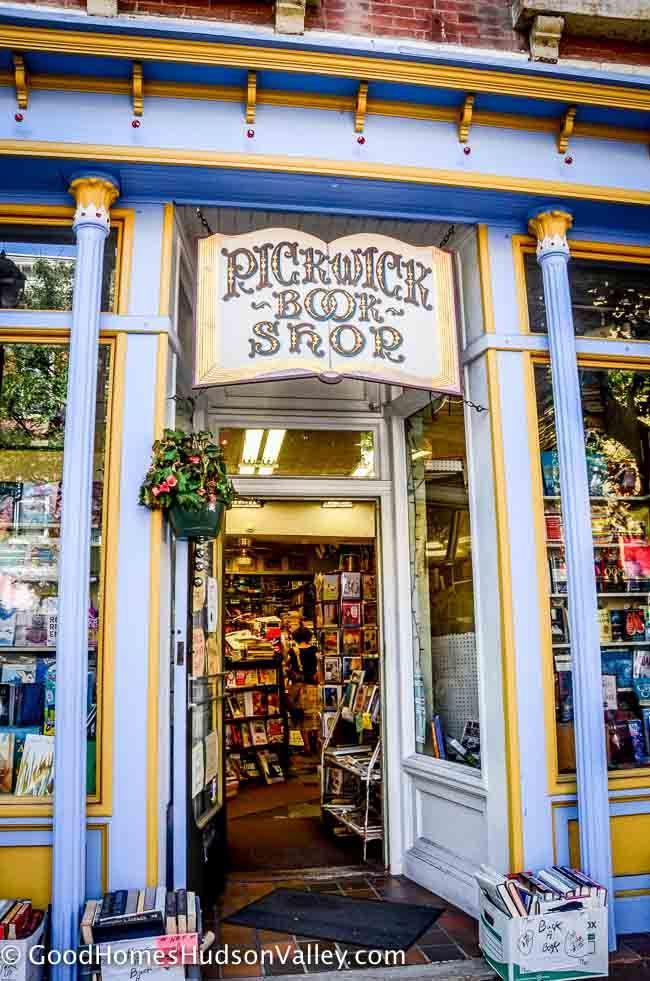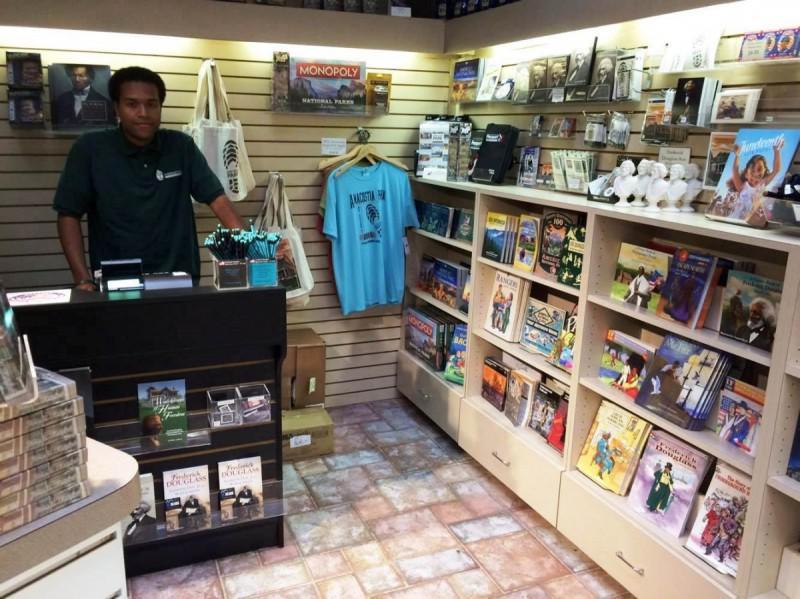The first image is the image on the left, the second image is the image on the right. Analyze the images presented: Is the assertion "Both images shown the exterior of a bookstore." valid? Answer yes or no. No. The first image is the image on the left, the second image is the image on the right. For the images displayed, is the sentence "An image shows multiple non-hanging containers of flowering plants in front of a shop's exterior." factually correct? Answer yes or no. No. 